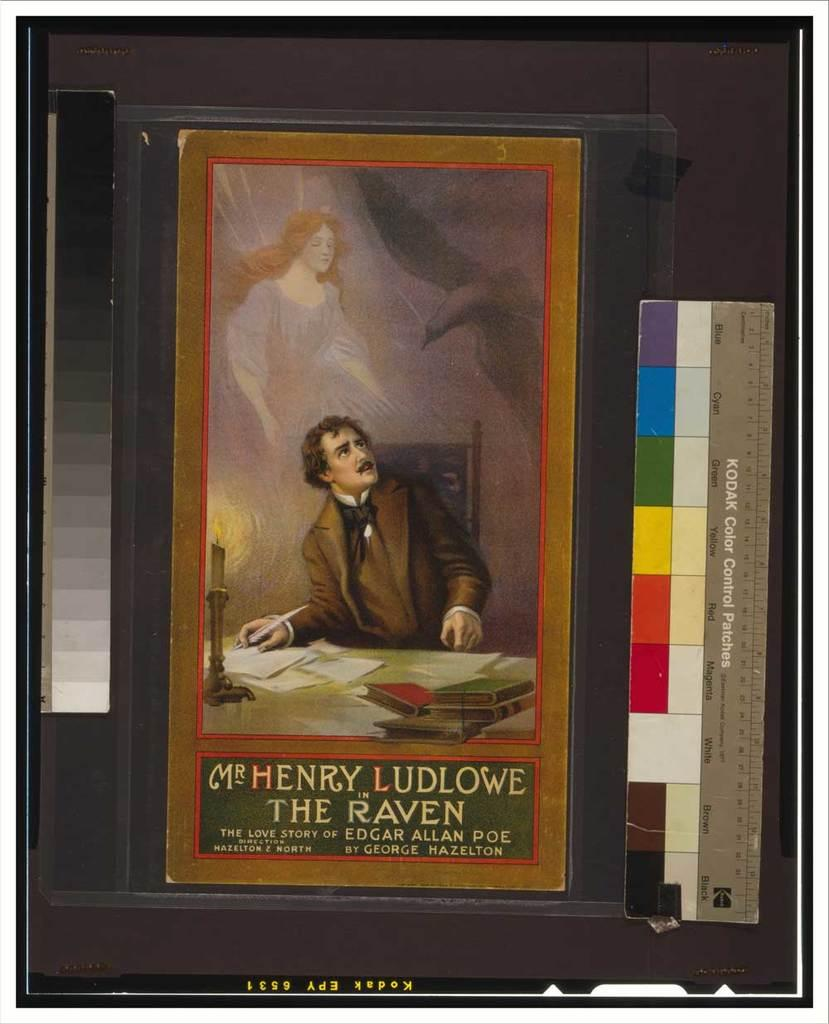What is the main object in the image? There is a book in the image. What can be seen at the bottom of the book? The book has pictures and text at the bottom. Where are the color scales located on the book? There are color scales on both the right and left sides of the book. Is there any text at the bottom of the book? Yes, there is text at the bottom of the book. Can you see any trains in the image? There are no trains present in the image; it features a book with pictures, text, and color scales. Is there a swing visible in the image? There is no swing present in the image. 